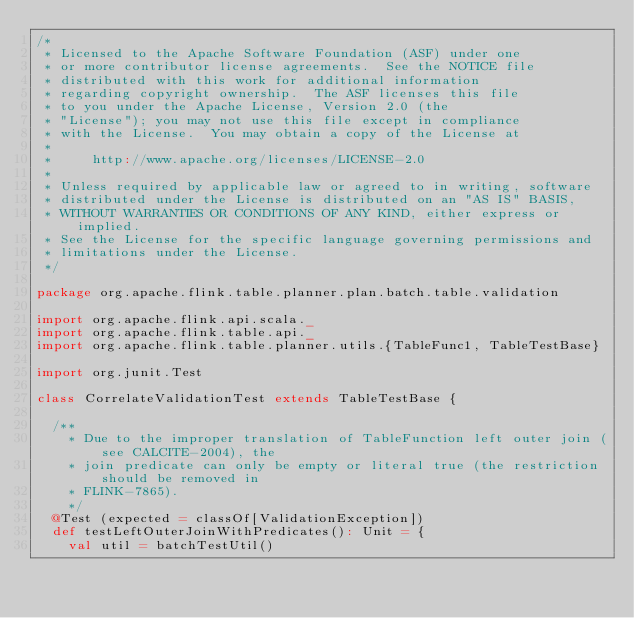<code> <loc_0><loc_0><loc_500><loc_500><_Scala_>/*
 * Licensed to the Apache Software Foundation (ASF) under one
 * or more contributor license agreements.  See the NOTICE file
 * distributed with this work for additional information
 * regarding copyright ownership.  The ASF licenses this file
 * to you under the Apache License, Version 2.0 (the
 * "License"); you may not use this file except in compliance
 * with the License.  You may obtain a copy of the License at
 *
 *     http://www.apache.org/licenses/LICENSE-2.0
 *
 * Unless required by applicable law or agreed to in writing, software
 * distributed under the License is distributed on an "AS IS" BASIS,
 * WITHOUT WARRANTIES OR CONDITIONS OF ANY KIND, either express or implied.
 * See the License for the specific language governing permissions and
 * limitations under the License.
 */

package org.apache.flink.table.planner.plan.batch.table.validation

import org.apache.flink.api.scala._
import org.apache.flink.table.api._
import org.apache.flink.table.planner.utils.{TableFunc1, TableTestBase}

import org.junit.Test

class CorrelateValidationTest extends TableTestBase {

  /**
    * Due to the improper translation of TableFunction left outer join (see CALCITE-2004), the
    * join predicate can only be empty or literal true (the restriction should be removed in
    * FLINK-7865).
    */
  @Test (expected = classOf[ValidationException])
  def testLeftOuterJoinWithPredicates(): Unit = {
    val util = batchTestUtil()</code> 